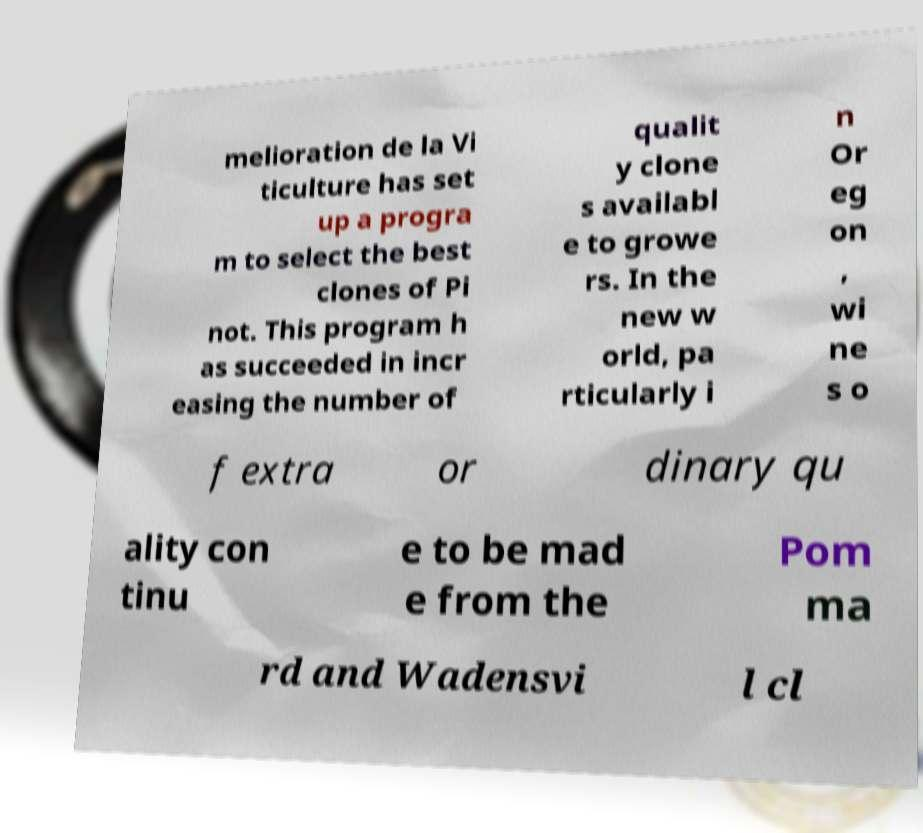Please read and relay the text visible in this image. What does it say? melioration de la Vi ticulture has set up a progra m to select the best clones of Pi not. This program h as succeeded in incr easing the number of qualit y clone s availabl e to growe rs. In the new w orld, pa rticularly i n Or eg on , wi ne s o f extra or dinary qu ality con tinu e to be mad e from the Pom ma rd and Wadensvi l cl 